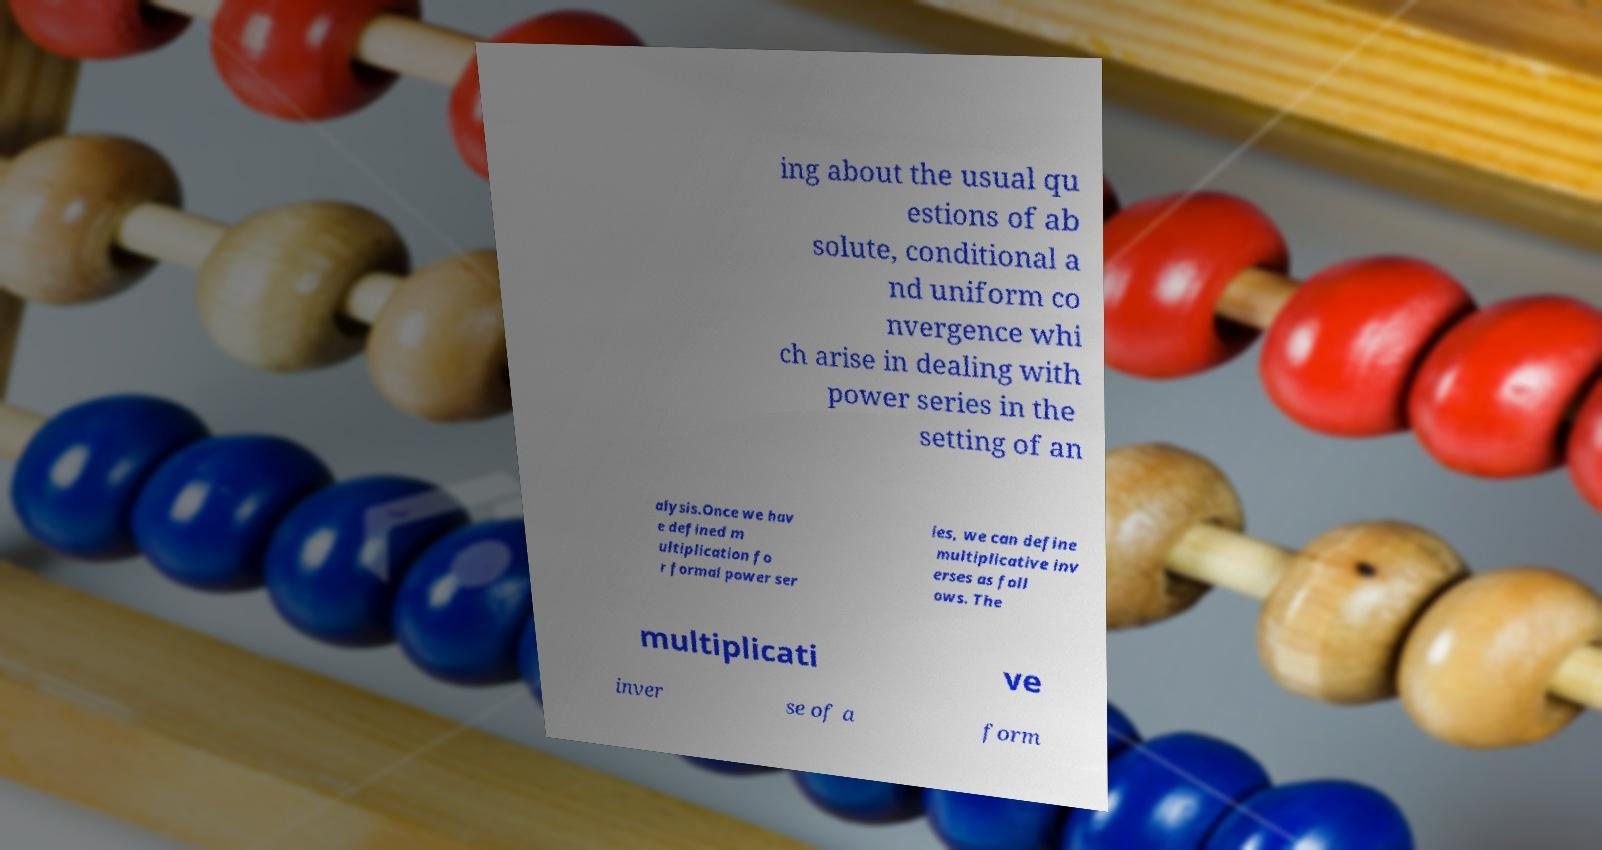Could you extract and type out the text from this image? ing about the usual qu estions of ab solute, conditional a nd uniform co nvergence whi ch arise in dealing with power series in the setting of an alysis.Once we hav e defined m ultiplication fo r formal power ser ies, we can define multiplicative inv erses as foll ows. The multiplicati ve inver se of a form 